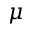Convert formula to latex. <formula><loc_0><loc_0><loc_500><loc_500>\mu</formula> 